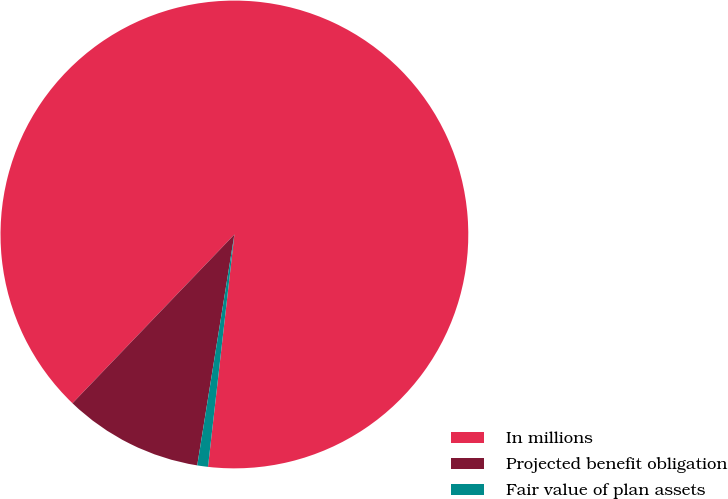<chart> <loc_0><loc_0><loc_500><loc_500><pie_chart><fcel>In millions<fcel>Projected benefit obligation<fcel>Fair value of plan assets<nl><fcel>89.63%<fcel>9.63%<fcel>0.74%<nl></chart> 